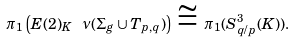Convert formula to latex. <formula><loc_0><loc_0><loc_500><loc_500>\pi _ { 1 } \left ( E ( 2 ) _ { K } \ \nu ( \Sigma _ { g } \cup T _ { p , q } ) \right ) \, \cong \, \pi _ { 1 } ( S ^ { 3 } _ { q / p } ( K ) ) .</formula> 